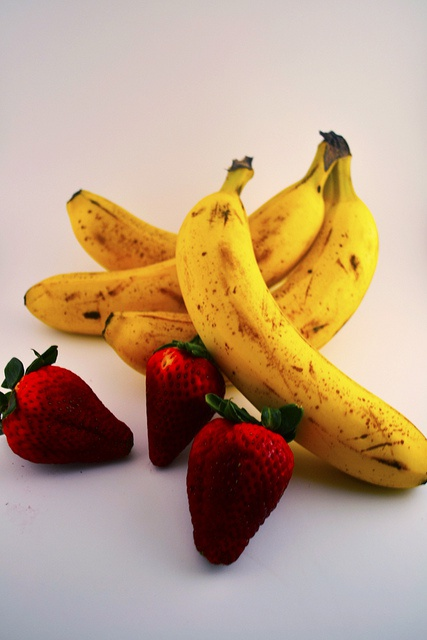Describe the objects in this image and their specific colors. I can see banana in darkgray, orange, red, and gold tones and banana in darkgray, orange, gold, and red tones in this image. 